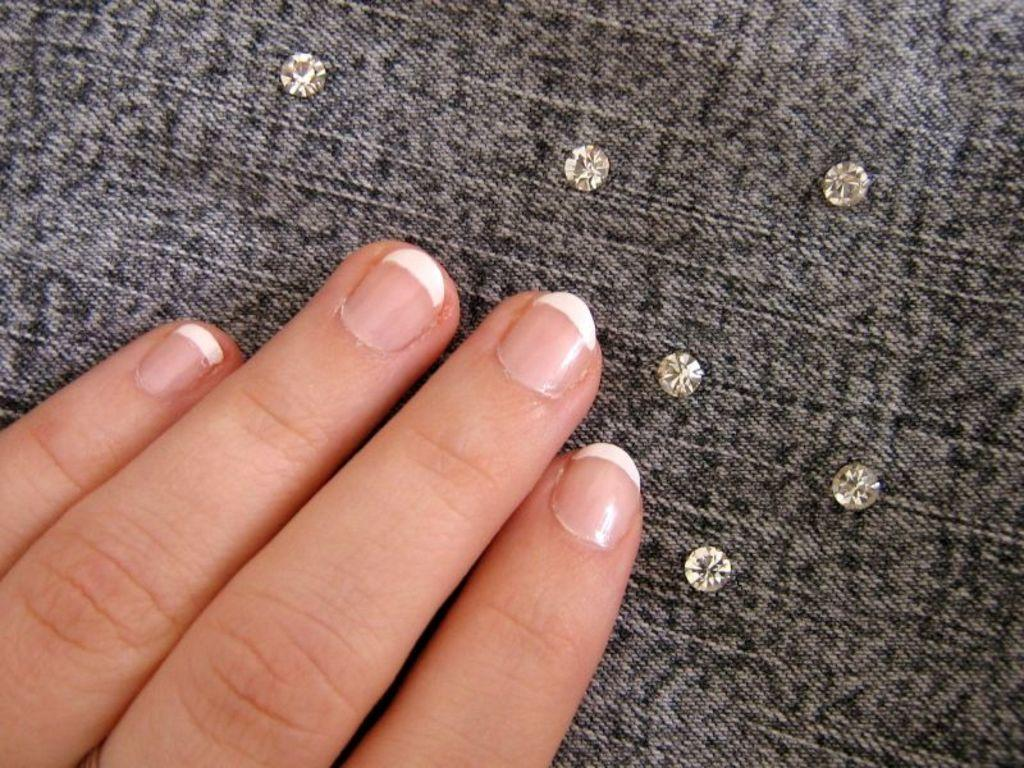What part of a person's body is visible in the image? There is a person's hand in the image. What can be seen on the cloth in the image? There are buttons on the cloth in the image. How does the spoon help the person rest in the image? There is no spoon present in the image, and therefore it cannot help the person rest. 